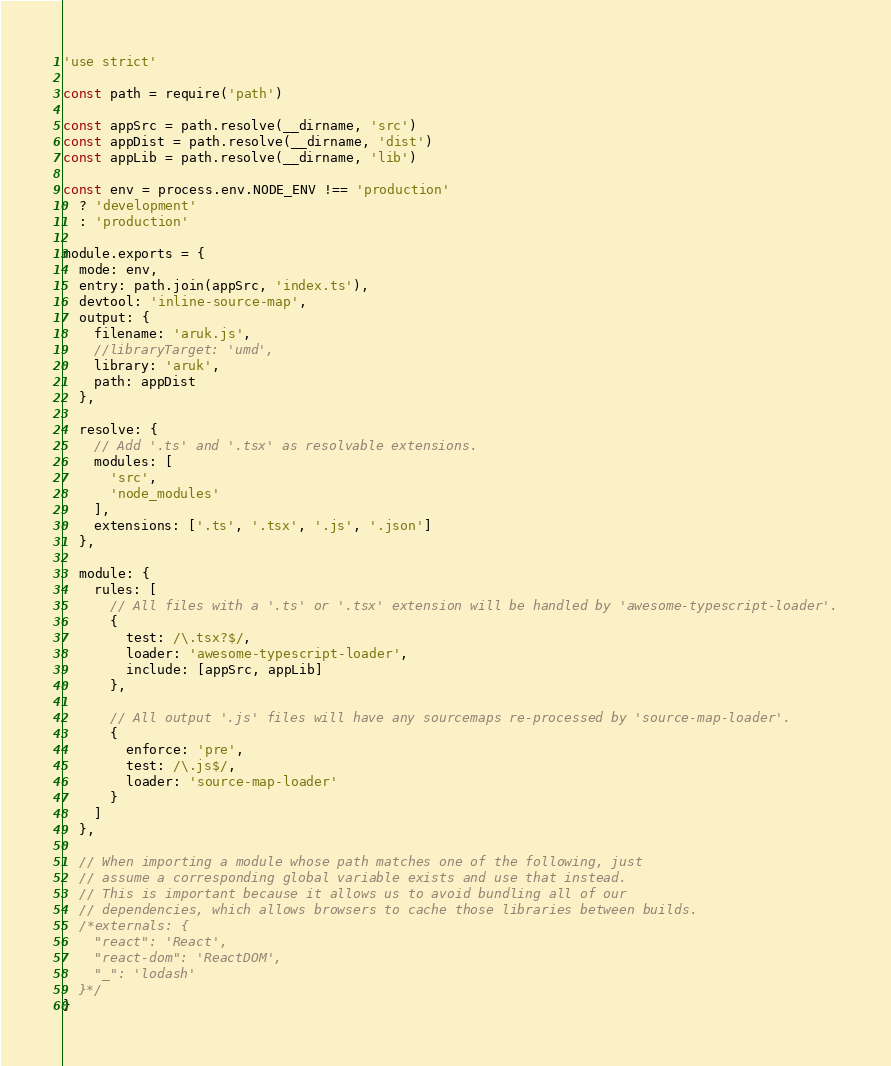Convert code to text. <code><loc_0><loc_0><loc_500><loc_500><_JavaScript_>'use strict'

const path = require('path')

const appSrc = path.resolve(__dirname, 'src')
const appDist = path.resolve(__dirname, 'dist')
const appLib = path.resolve(__dirname, 'lib')

const env = process.env.NODE_ENV !== 'production'
  ? 'development'
  : 'production'

module.exports = {
  mode: env,
  entry: path.join(appSrc, 'index.ts'),
  devtool: 'inline-source-map',
  output: {
    filename: 'aruk.js',
    //libraryTarget: 'umd',
    library: 'aruk',
    path: appDist
  },

  resolve: {
    // Add '.ts' and '.tsx' as resolvable extensions.
    modules: [
      'src',
      'node_modules'
    ],
    extensions: ['.ts', '.tsx', '.js', '.json']
  },

  module: {
    rules: [
      // All files with a '.ts' or '.tsx' extension will be handled by 'awesome-typescript-loader'.
      {
        test: /\.tsx?$/,
        loader: 'awesome-typescript-loader',
        include: [appSrc, appLib]
      },

      // All output '.js' files will have any sourcemaps re-processed by 'source-map-loader'.
      {
        enforce: 'pre',
        test: /\.js$/,
        loader: 'source-map-loader'
      }
    ]
  },

  // When importing a module whose path matches one of the following, just
  // assume a corresponding global variable exists and use that instead.
  // This is important because it allows us to avoid bundling all of our
  // dependencies, which allows browsers to cache those libraries between builds.
  /*externals: {
    "react": 'React',
    "react-dom": 'ReactDOM',
    "_": 'lodash'
  }*/
}
</code> 